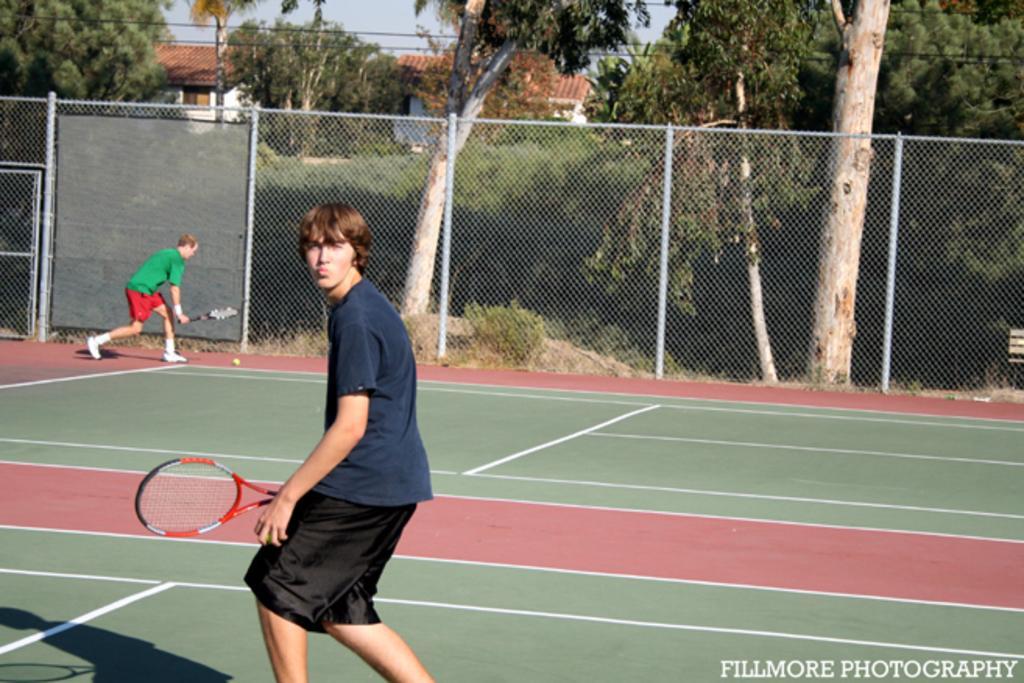Please provide a concise description of this image. a person is standing in a blue t shirt holding a racket. behind him there is another person wearing green t shirt. behind them there is a fencing and trees. at the back there are buildings 